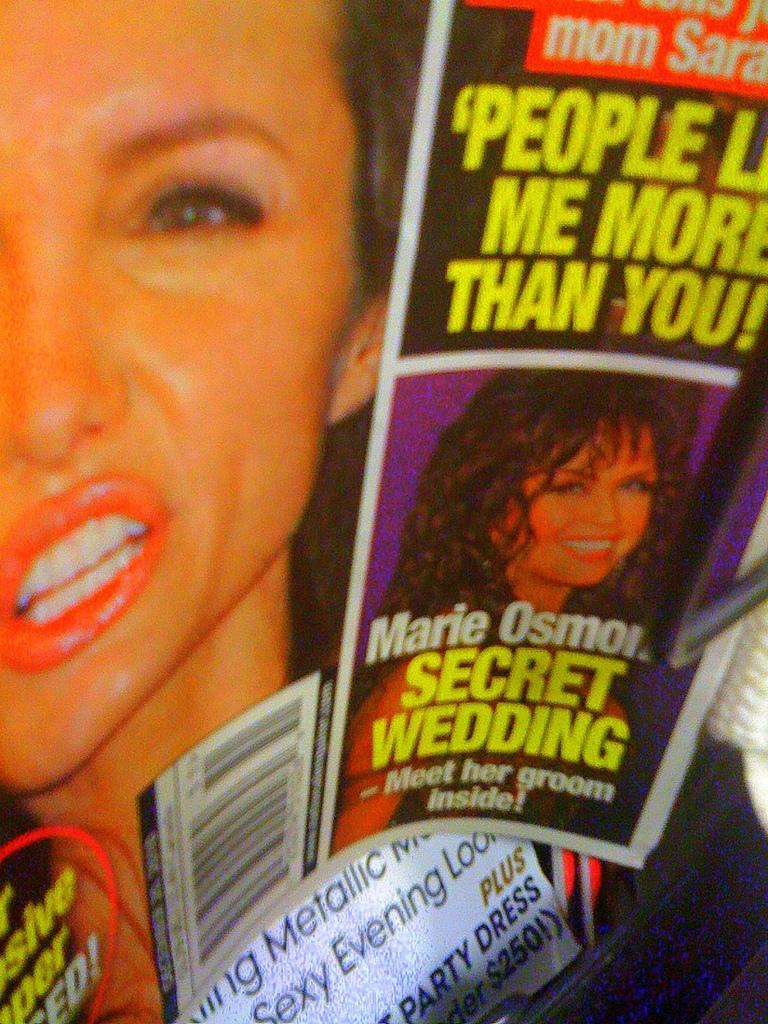Describe this image in one or two sentences. In this picture, we can see a few posters with some text and images on it. 